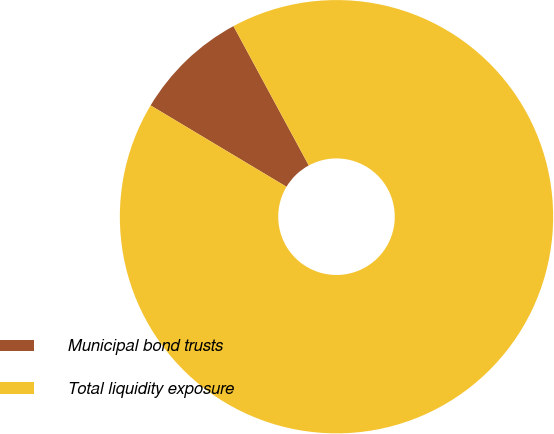<chart> <loc_0><loc_0><loc_500><loc_500><pie_chart><fcel>Municipal bond trusts<fcel>Total liquidity exposure<nl><fcel>8.53%<fcel>91.47%<nl></chart> 